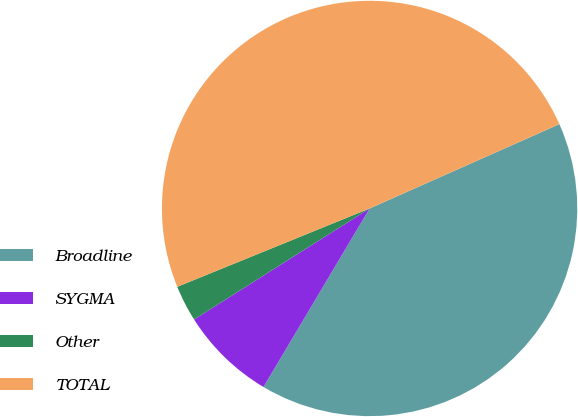Convert chart. <chart><loc_0><loc_0><loc_500><loc_500><pie_chart><fcel>Broadline<fcel>SYGMA<fcel>Other<fcel>TOTAL<nl><fcel>40.19%<fcel>7.49%<fcel>2.82%<fcel>49.5%<nl></chart> 